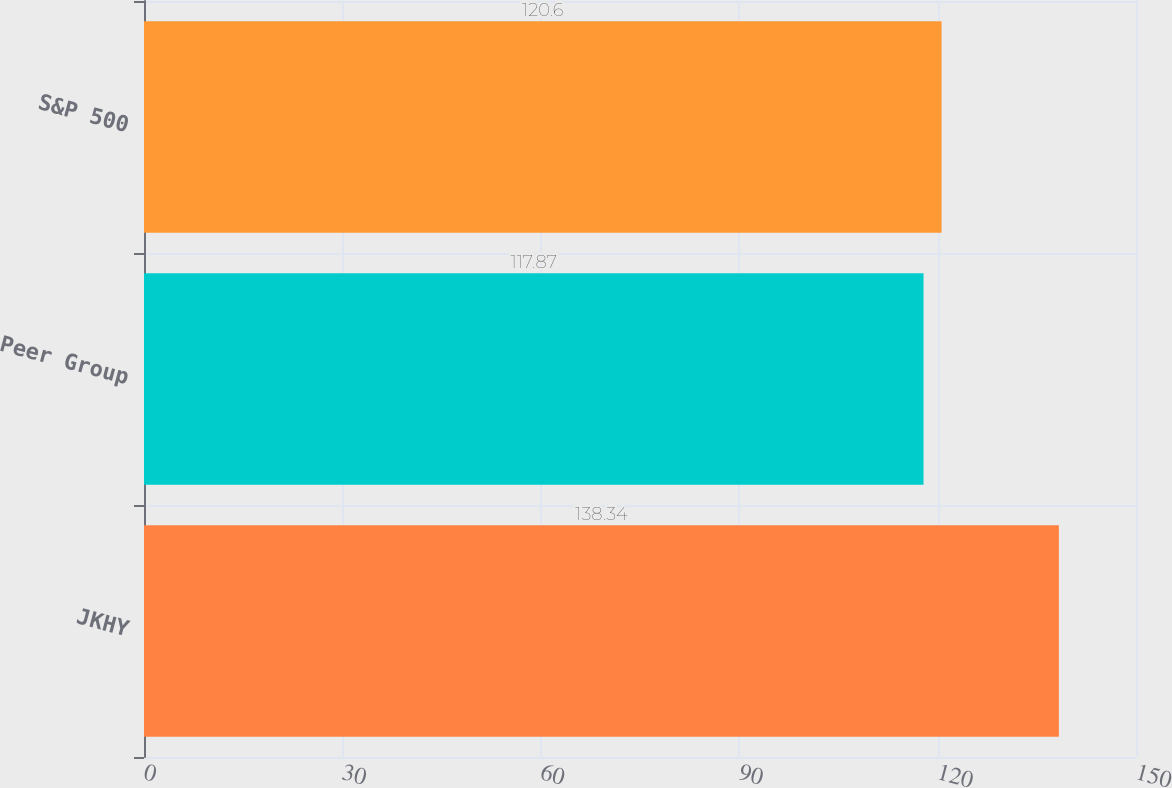<chart> <loc_0><loc_0><loc_500><loc_500><bar_chart><fcel>JKHY<fcel>Peer Group<fcel>S&P 500<nl><fcel>138.34<fcel>117.87<fcel>120.6<nl></chart> 